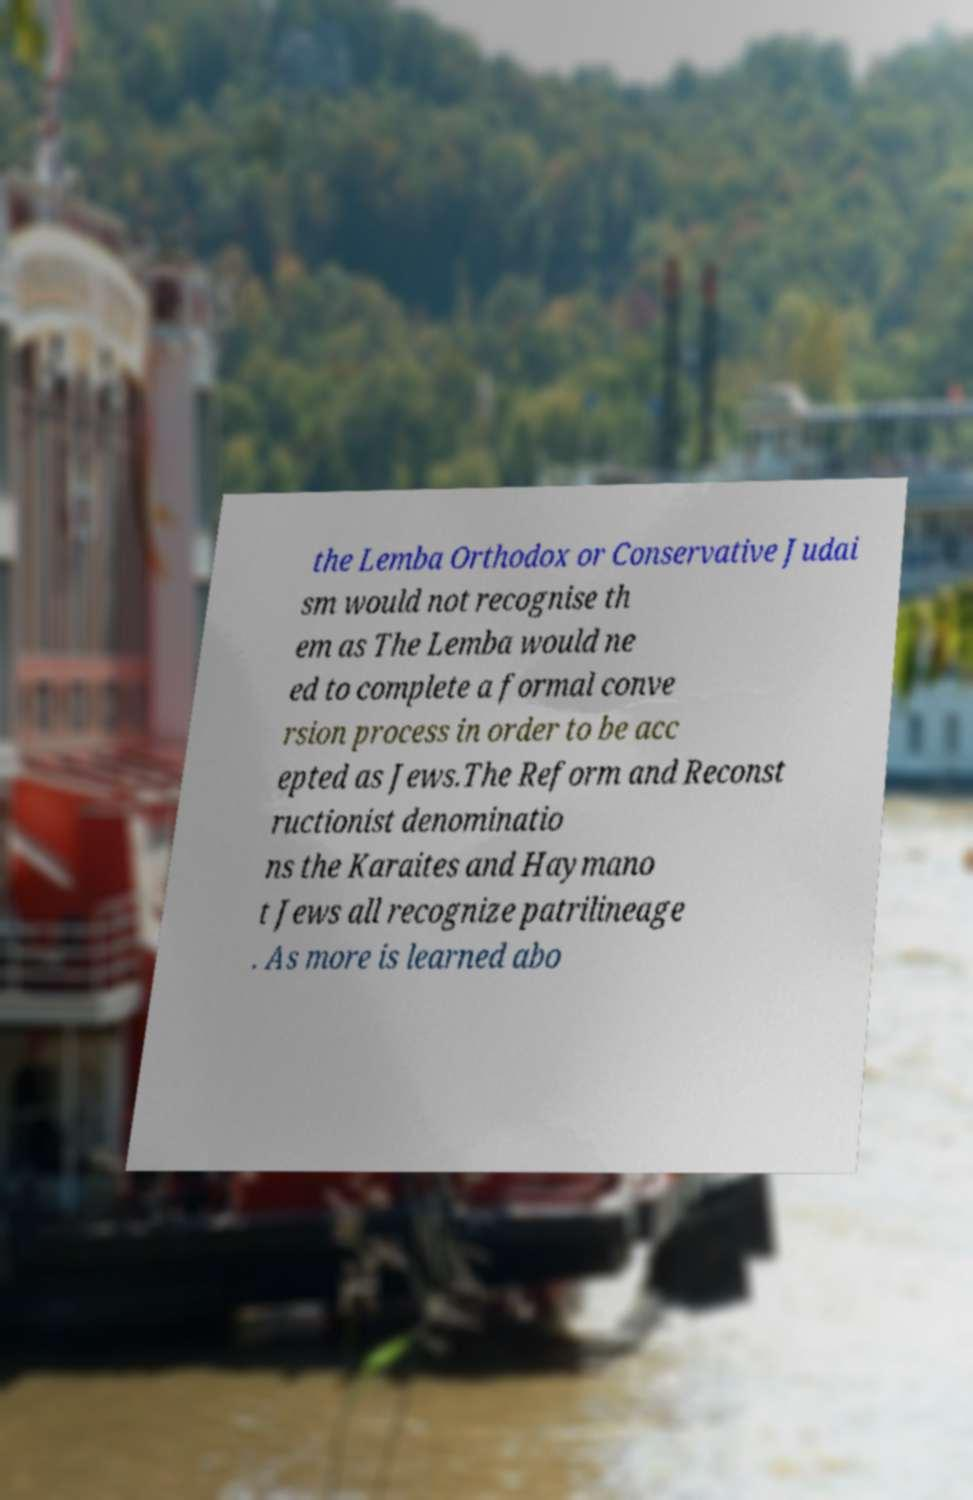What messages or text are displayed in this image? I need them in a readable, typed format. the Lemba Orthodox or Conservative Judai sm would not recognise th em as The Lemba would ne ed to complete a formal conve rsion process in order to be acc epted as Jews.The Reform and Reconst ructionist denominatio ns the Karaites and Haymano t Jews all recognize patrilineage . As more is learned abo 